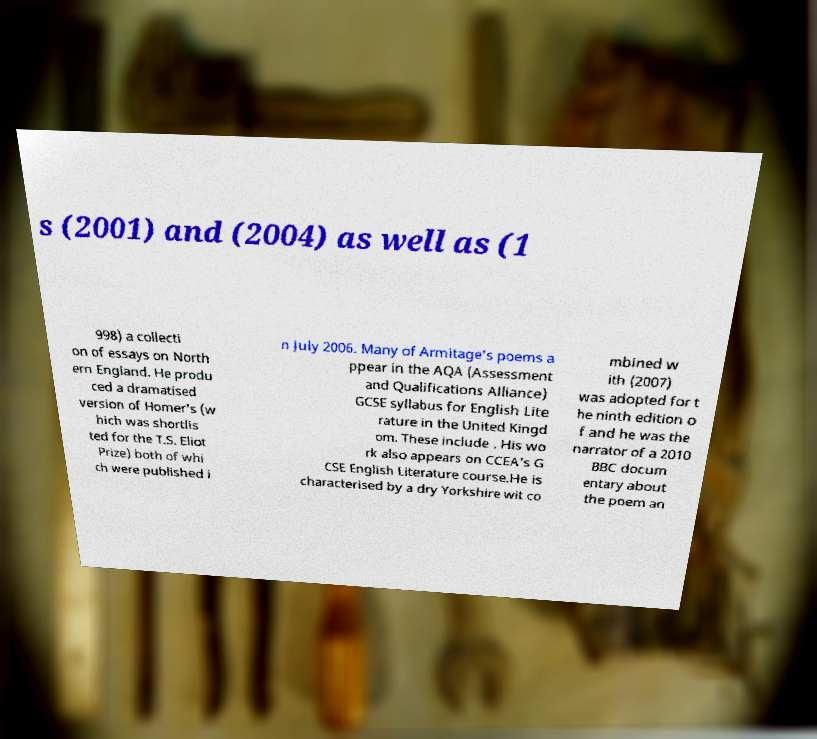Could you assist in decoding the text presented in this image and type it out clearly? s (2001) and (2004) as well as (1 998) a collecti on of essays on North ern England. He produ ced a dramatised version of Homer's (w hich was shortlis ted for the T.S. Eliot Prize) both of whi ch were published i n July 2006. Many of Armitage's poems a ppear in the AQA (Assessment and Qualifications Alliance) GCSE syllabus for English Lite rature in the United Kingd om. These include . His wo rk also appears on CCEA's G CSE English Literature course.He is characterised by a dry Yorkshire wit co mbined w ith (2007) was adopted for t he ninth edition o f and he was the narrator of a 2010 BBC docum entary about the poem an 